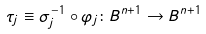Convert formula to latex. <formula><loc_0><loc_0><loc_500><loc_500>\tau _ { j } \equiv \sigma _ { j } ^ { - 1 } \circ \varphi _ { j } \colon B ^ { n + 1 } \rightarrow B ^ { n + 1 }</formula> 